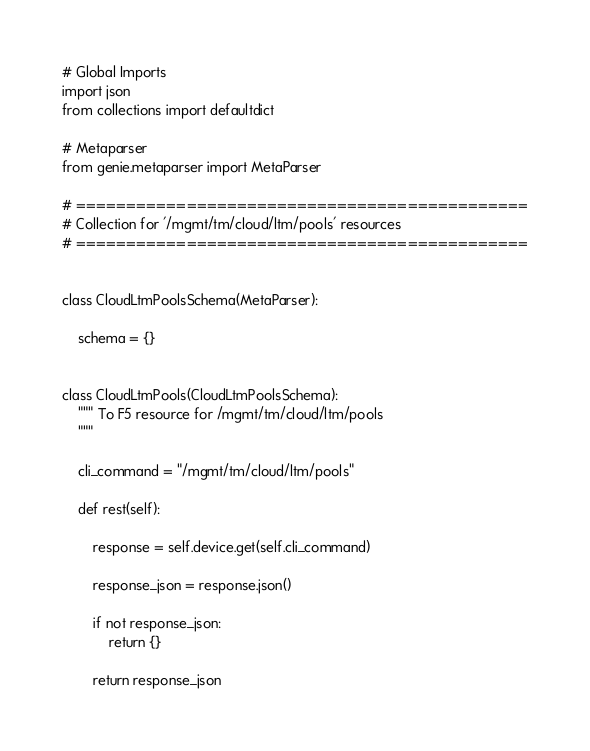<code> <loc_0><loc_0><loc_500><loc_500><_Python_># Global Imports
import json
from collections import defaultdict

# Metaparser
from genie.metaparser import MetaParser

# =============================================
# Collection for '/mgmt/tm/cloud/ltm/pools' resources
# =============================================


class CloudLtmPoolsSchema(MetaParser):

    schema = {}


class CloudLtmPools(CloudLtmPoolsSchema):
    """ To F5 resource for /mgmt/tm/cloud/ltm/pools
    """

    cli_command = "/mgmt/tm/cloud/ltm/pools"

    def rest(self):

        response = self.device.get(self.cli_command)

        response_json = response.json()

        if not response_json:
            return {}

        return response_json
</code> 